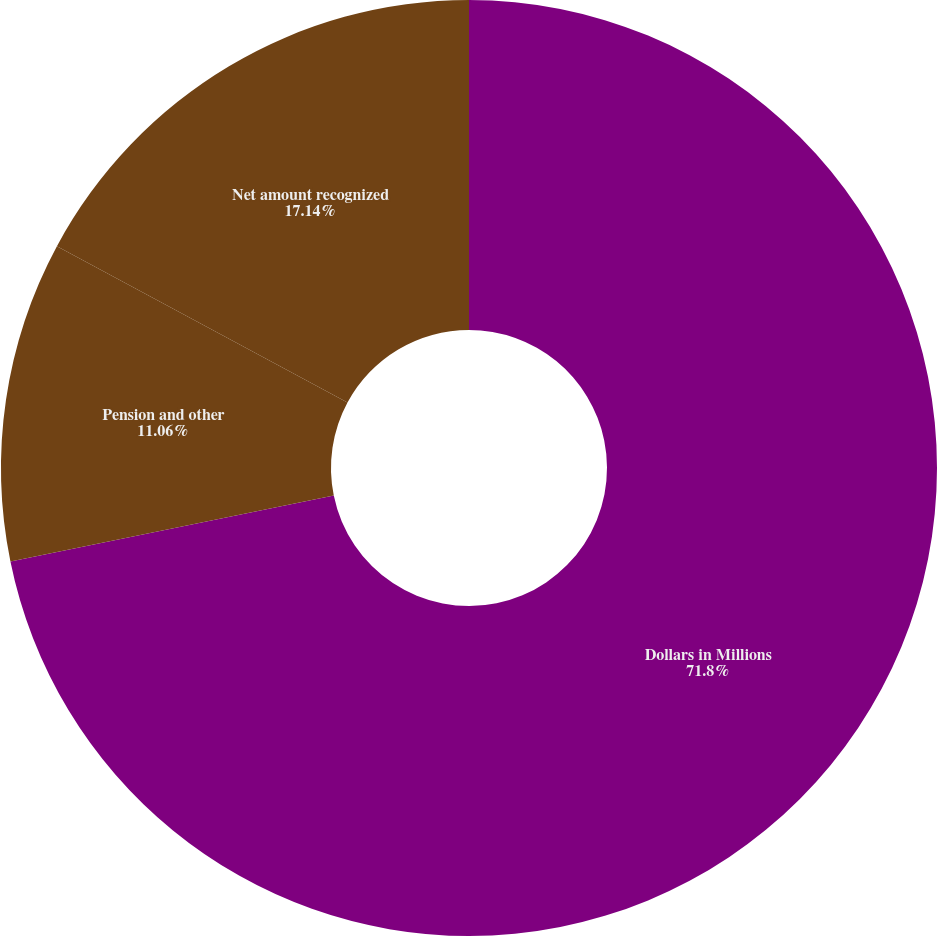Convert chart. <chart><loc_0><loc_0><loc_500><loc_500><pie_chart><fcel>Dollars in Millions<fcel>Pension and other<fcel>Net amount recognized<nl><fcel>71.8%<fcel>11.06%<fcel>17.14%<nl></chart> 